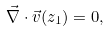Convert formula to latex. <formula><loc_0><loc_0><loc_500><loc_500>\vec { \nabla } \cdot \vec { v } ( z _ { 1 } ) = 0 ,</formula> 